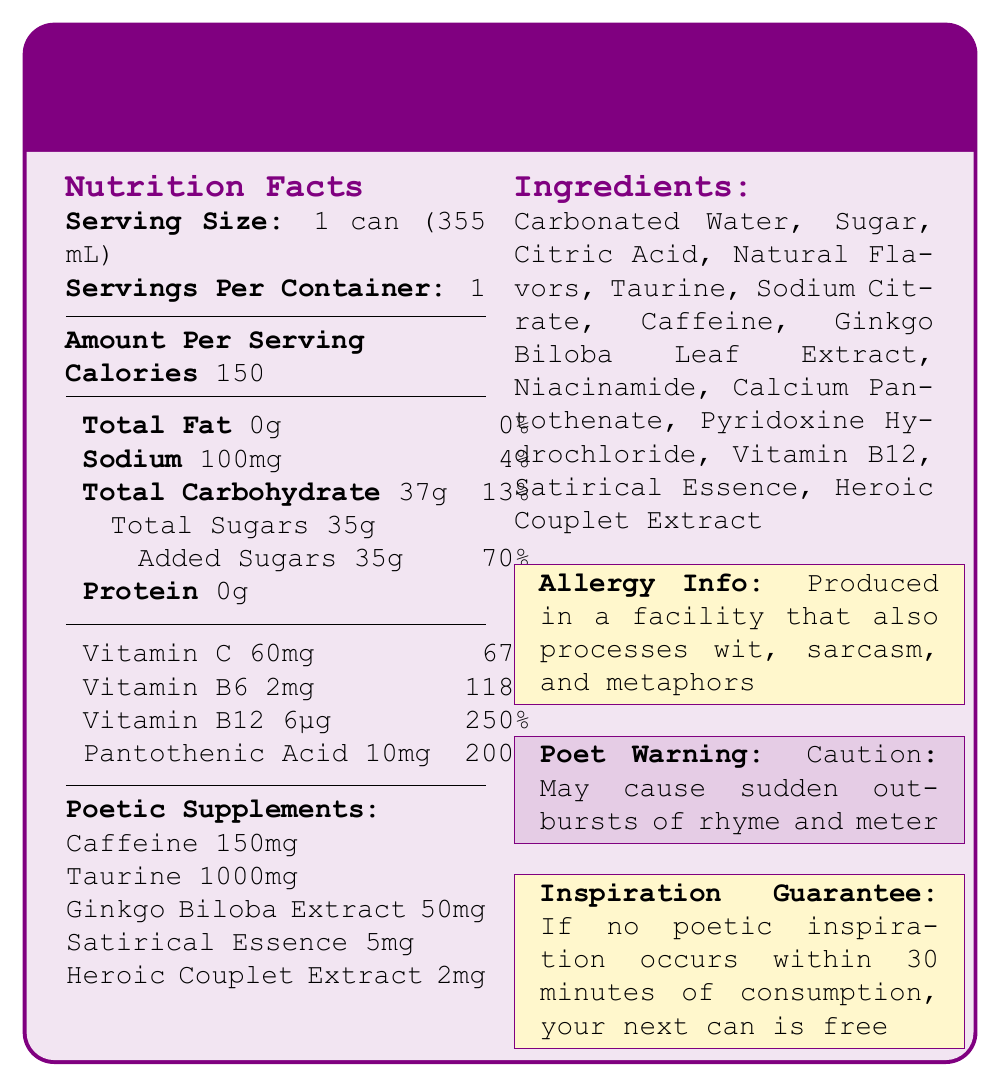what is the serving size of the Poetic Inspiration Energy Drink? The serving size is explicitly mentioned as "1 can (355 mL)" under the "Nutrition Facts" section.
Answer: 1 can (355 mL) how many calories are in one serving of the Poetic Inspiration Energy Drink? The number of calories per serving is clearly listed as "150" in the "Amount Per Serving" section.
Answer: 150 what is the total carbohydrate content per serving? The total carbohydrate content per serving is stated as "Total Carbohydrate 37g" in the nutritional information table.
Answer: 37g how much added sugar is in one serving of the Poetic Inspiration Energy Drink? The amount of added sugars per serving is given as "Added Sugars 35g" under the total carbohydrate section.
Answer: 35g what is the percentage of daily value for vitamin B12 provided by this drink? The percentage of daily value for vitamin B12 is listed as "250%" in the vitamins and supplements table.
Answer: 250% which of the following is not an ingredient in the Poetic Inspiration Energy Drink? A. Caffeine B. Honey C. Natural Flavors D. Taurine Among the options, "Honey" is not listed in the ingredients section, while the others are.
Answer: B. Honey what ingredient might cause an allergic reaction due to its comedic properties? A. Natural Flavors B. Taurine C. Citric Acid D. Wit, sarcasm, and metaphors The allergy information notes that the drink is produced in a facility that processes "wit, sarcasm, and metaphors."
Answer: D. Wit, sarcasm, and metaphors does the Poetic Inspiration Energy Drink offer any guarantee related to inspiration? The document mentions, "If no poetic inspiration occurs within 30 minutes of consumption, your next can is free," under the Inspiration Guarantee section.
Answer: Yes what is the main idea of the document? The document provides detailed nutritional information, ingredients, and various warnings and guarantees for the Poetic Inspiration Energy Drink.
Answer: Description and nutritional information of the Poetic Inspiration Energy Drink what are the health benefits of Ginkgo Biloba Extract in the drink? The document only mentions the presence of Ginkgo Biloba Extract (50mg) but does not elaborate on its potential health benefits.
Answer: Not enough information what warning does the Poetic Inspiration Energy Drink carry for poets? The Poet Warning section states "Caution: May cause sudden outbursts of rhyme and meter."
Answer: Caution: May cause sudden outbursts of rhyme and meter how much pantothenic acid is in one serving, and what is its daily value percentage? The document lists "Pantothenic Acid 10mg" with a daily value percentage of "200%."
Answer: 10mg, 200% how many milligrams of caffeine does the drink contain? The drink contains "Caffeine 150mg," as mentioned under the Poetic Supplements section.
Answer: 150mg how much taurine is included in one serving of the drink? According to the Poetic Supplements section, the drink includes "Taurine 1000mg" per serving.
Answer: 1000mg does the document specify the processor of metaphors as one of the ingredients? The document mentions that the facility processes metaphors as part of the allergy information but does not list it as an ingredient.
Answer: No describe the appearance of the document The document uses colors (poeticpurple, inspirationgold), and fonts (Courier New), and contains sections on nutrition facts, ingredients, and specific warnings and guarantees related to poetic inspiration.
Answer: The document is set in a whimsical and poetic style using colors like poetic purple and inspiration gold, with a detailed layout showing nutrition facts, ingredients, and warnings. 